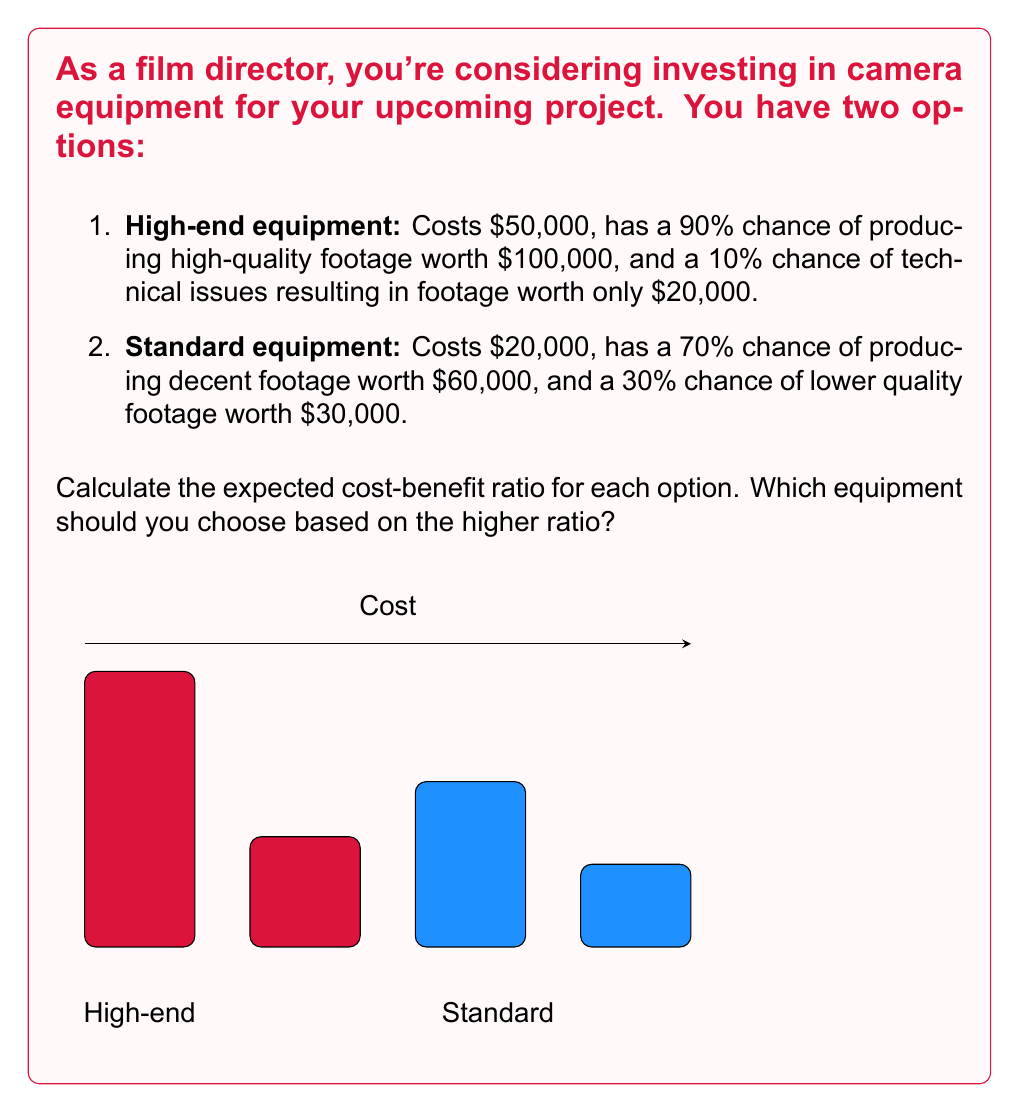Teach me how to tackle this problem. Let's calculate the expected value and cost-benefit ratio for each option:

1. High-end equipment:

Expected Value (EV):
$EV_{high} = 0.90 \times \$100,000 + 0.10 \times \$20,000 = \$92,000$

Cost-Benefit Ratio:
$$\text{Ratio}_{high} = \frac{EV_{high}}{\text{Cost}_{high}} = \frac{\$92,000}{\$50,000} = 1.84$$

2. Standard equipment:

Expected Value (EV):
$EV_{standard} = 0.70 \times \$60,000 + 0.30 \times \$30,000 = \$51,000$

Cost-Benefit Ratio:
$$\text{Ratio}_{standard} = \frac{EV_{standard}}{\text{Cost}_{standard}} = \frac{\$51,000}{\$20,000} = 2.55$$

Comparing the ratios:
The standard equipment has a higher cost-benefit ratio (2.55) compared to the high-end equipment (1.84).
Answer: Choose standard equipment (ratio 2.55 vs 1.84) 